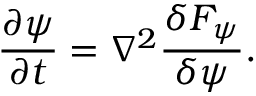Convert formula to latex. <formula><loc_0><loc_0><loc_500><loc_500>\frac { \partial \psi } { \partial t } = \nabla ^ { 2 } \frac { \delta F _ { \psi } } { \delta \psi } .</formula> 